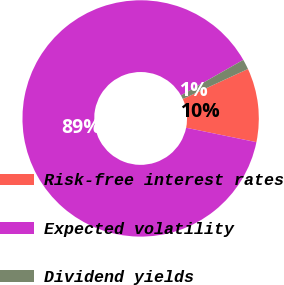Convert chart to OTSL. <chart><loc_0><loc_0><loc_500><loc_500><pie_chart><fcel>Risk-free interest rates<fcel>Expected volatility<fcel>Dividend yields<nl><fcel>10.09%<fcel>88.53%<fcel>1.38%<nl></chart> 